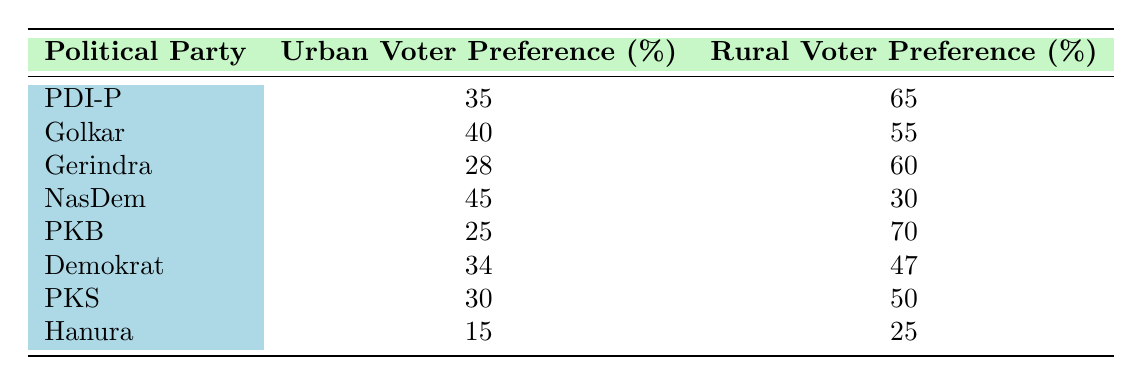What is the urban voter preference percentage for Golkar? From the table, the urban voter preference for Golkar is directly stated as 40%.
Answer: 40 Which political party has the highest rural voter preference? The rural voter preference percentages are as follows: PDI-P (65%), Golkar (55%), Gerindra (60%), NasDem (30%), PKB (70%), Demokrat (47%), PKS (50%), Hanura (25%). The highest is PKB with 70%.
Answer: PKB What is the average urban voter preference across all listed political parties? The urban voter preference percentages are: 35, 40, 28, 45, 25, 34, 30, 15. Adding these values gives 35 + 40 + 28 + 45 + 25 + 34 + 30 + 15 = 252. There are 8 political parties, so the average is 252 / 8 = 31.5.
Answer: 31.5 Is the rural voter preference for NasDem greater than that for Democrat? The rural voter preference for NasDem is 30% and for Democrat is 47%. Since 30% is not greater than 47%, the answer is no.
Answer: No Which political party has the largest difference between urban and rural voter preferences? To find the largest difference, we calculate the differences for each party: PDI-P (30), Golkar (15), Gerindra (32), NasDem (15), PKB (45), Demokrat (13), PKS (20), Hanura (10). The largest difference is for PKB with 45%.
Answer: PKB What is the sum of urban voter preferences for PDI-P and Hanura? The urban voter preferences are 35% for PDI-P and 15% for Hanura. Adding these gives 35 + 15 = 50.
Answer: 50 Which political party has a rural voter preference below 50%? Reviewing the rural voter preference: PDI-P (65%), Golkar (55%), Gerindra (60%), NasDem (30%), PKB (70%), Demokrat (47%), PKS (50%), and Hanura (25%). The parties below 50% are NasDem (30%) and Hanura (25%).
Answer: NasDem and Hanura Does Golkar have a higher urban voter preference than PDI-P? The urban preferences are 40% for Golkar and 35% for PDI-P. Since 40% is greater than 35%, the answer is yes.
Answer: Yes 